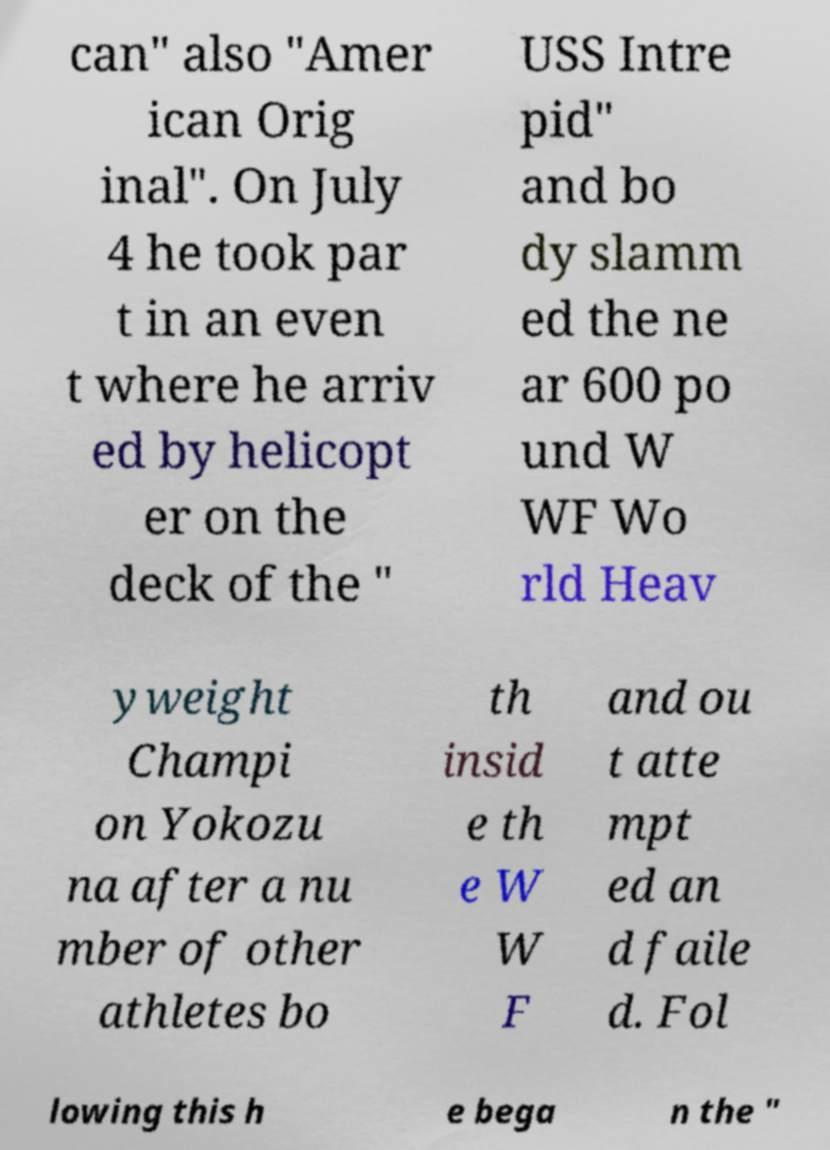Can you read and provide the text displayed in the image?This photo seems to have some interesting text. Can you extract and type it out for me? can" also "Amer ican Orig inal". On July 4 he took par t in an even t where he arriv ed by helicopt er on the deck of the " USS Intre pid" and bo dy slamm ed the ne ar 600 po und W WF Wo rld Heav yweight Champi on Yokozu na after a nu mber of other athletes bo th insid e th e W W F and ou t atte mpt ed an d faile d. Fol lowing this h e bega n the " 